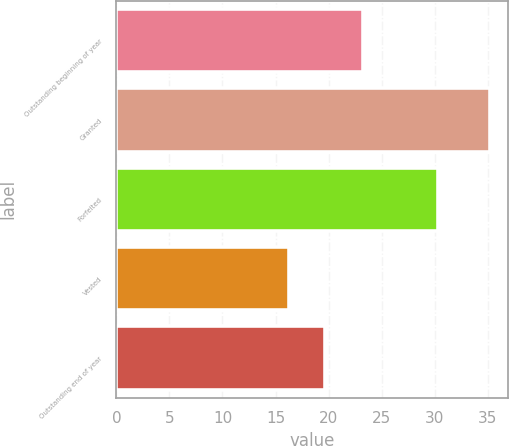<chart> <loc_0><loc_0><loc_500><loc_500><bar_chart><fcel>Outstanding beginning of year<fcel>Granted<fcel>Forfeited<fcel>Vested<fcel>Outstanding end of year<nl><fcel>23.23<fcel>35.2<fcel>30.35<fcel>16.25<fcel>19.68<nl></chart> 